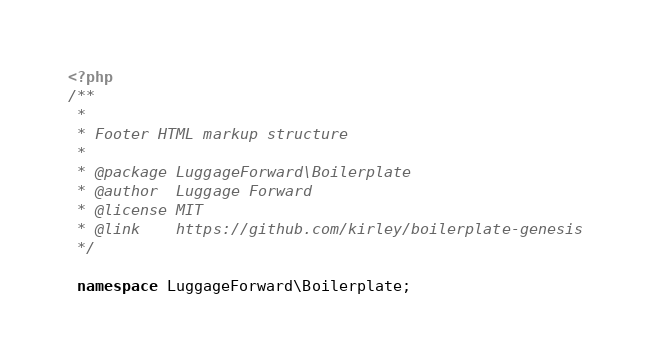Convert code to text. <code><loc_0><loc_0><loc_500><loc_500><_PHP_><?php
/**
 *
 * Footer HTML markup structure
 *
 * @package LuggageForward\Boilerplate
 * @author  Luggage Forward
 * @license MIT
 * @link    https://github.com/kirley/boilerplate-genesis
 */

 namespace LuggageForward\Boilerplate;
</code> 